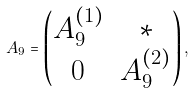Convert formula to latex. <formula><loc_0><loc_0><loc_500><loc_500>A _ { 9 } = \begin{pmatrix} A _ { 9 } ^ { ( 1 ) } & * \\ 0 & A _ { 9 } ^ { ( 2 ) } \end{pmatrix} ,</formula> 